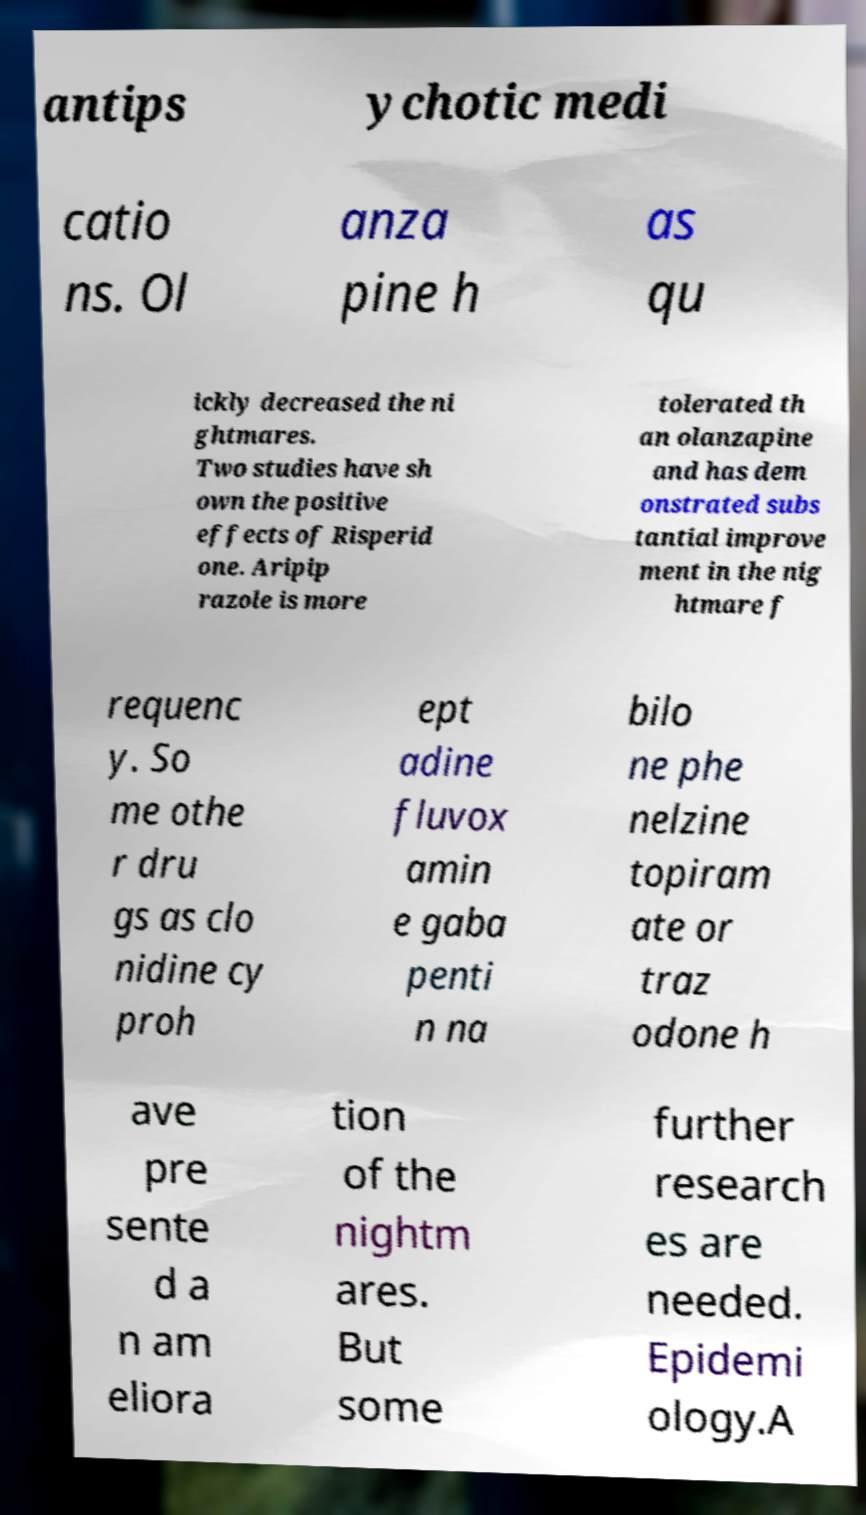Could you assist in decoding the text presented in this image and type it out clearly? antips ychotic medi catio ns. Ol anza pine h as qu ickly decreased the ni ghtmares. Two studies have sh own the positive effects of Risperid one. Aripip razole is more tolerated th an olanzapine and has dem onstrated subs tantial improve ment in the nig htmare f requenc y. So me othe r dru gs as clo nidine cy proh ept adine fluvox amin e gaba penti n na bilo ne phe nelzine topiram ate or traz odone h ave pre sente d a n am eliora tion of the nightm ares. But some further research es are needed. Epidemi ology.A 